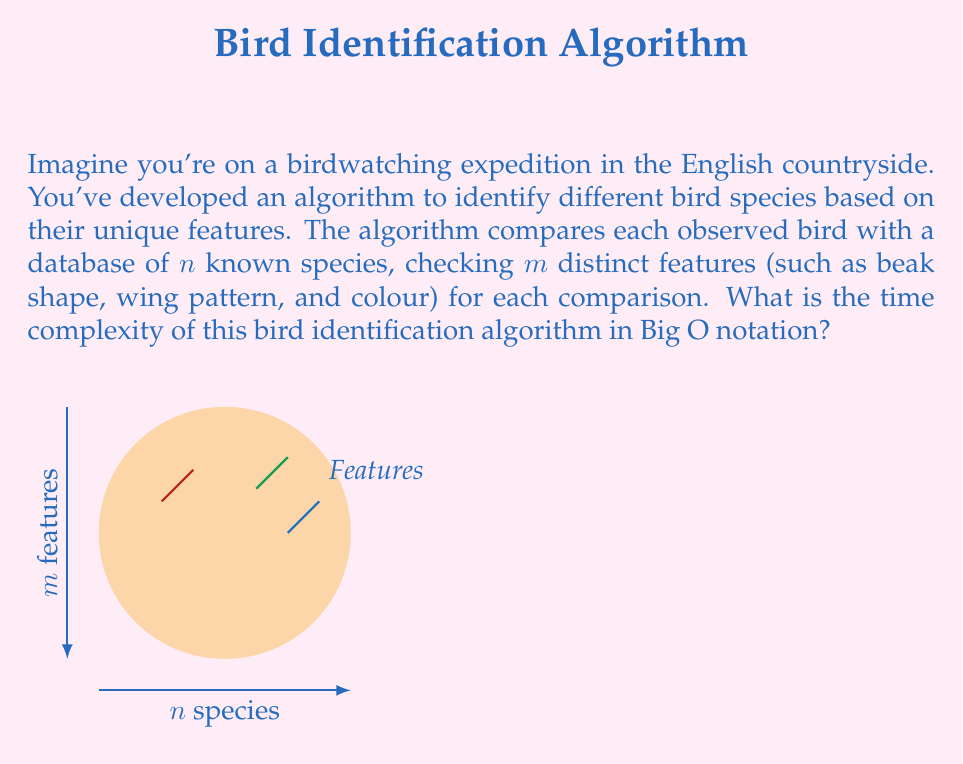Teach me how to tackle this problem. Let's break this down step-by-step:

1) For each observed bird, the algorithm needs to compare it with all $n$ known species in the database.

2) For each comparison, the algorithm checks $m$ distinct features.

3) This means that for each bird we're trying to identify, we perform $n \times m$ operations.

4) In Big O notation, we're interested in the worst-case scenario and the dominant term as the input size grows.

5) Both $n$ (number of species) and $m$ (number of features) are variables that can grow, and they multiply each other.

6) Therefore, the time complexity is $O(nm)$.

7) This is a linear time complexity with respect to both $n$ and $m$. If either the number of species or the number of features increases, the time taken by the algorithm will increase proportionally.

8) In the context of birdwatching, this means that as your bird database grows (more species) or as you check more features per bird, your identification process will take longer in a predictable, linear fashion.
Answer: $O(nm)$ 